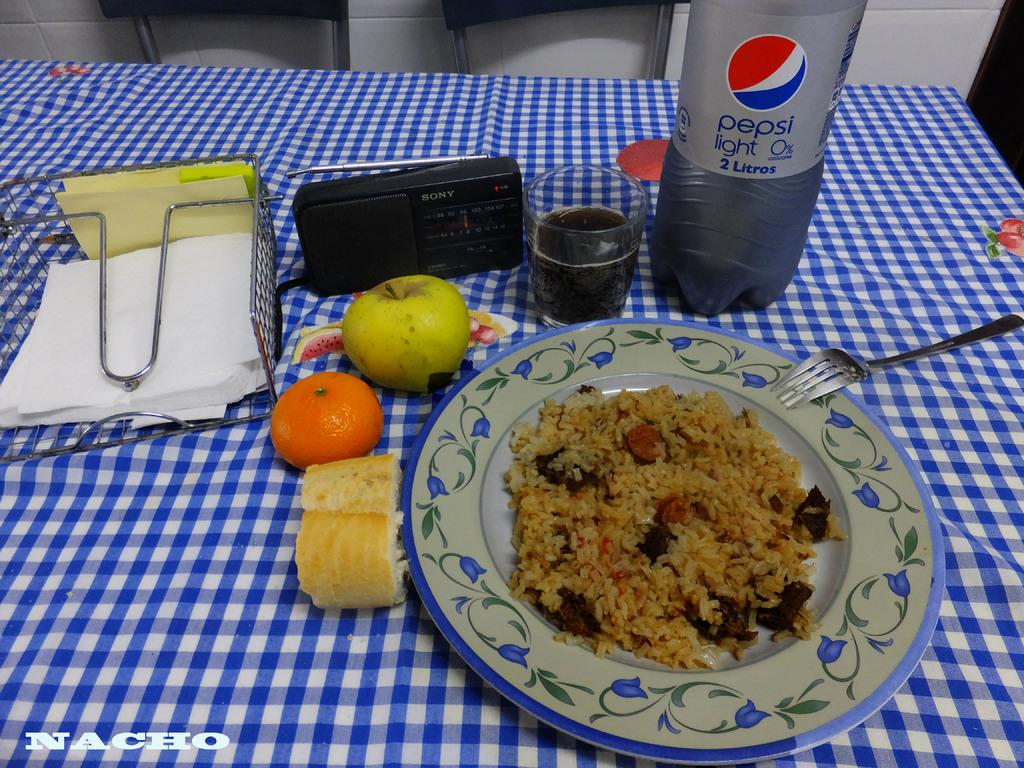What piece of furniture is in the image? There is a table in the image. What is on the table? There is a plate containing a food item, a fork, a bottle, a glass with a drink, fruits, and tissues on the table. What utensil is present on the table? A fork is present on the table. What can be used for cleaning or wiping on the table? Tissues are present on the table for cleaning or wiping. What type of clouds can be seen in the image? There are no clouds visible in the image, as it features a table with various items on it. 